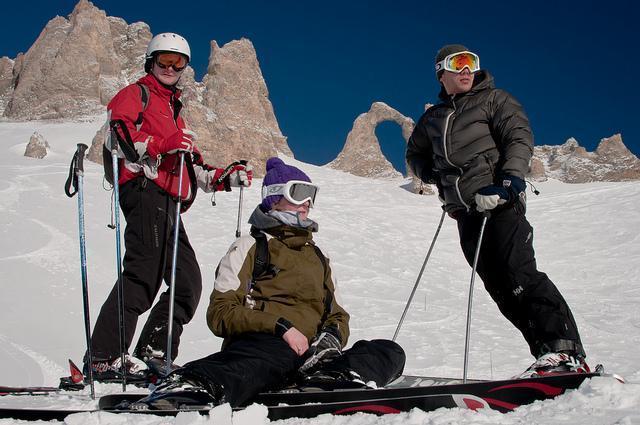How many people can be seen?
Give a very brief answer. 3. How many buses are in the photo?
Give a very brief answer. 0. 